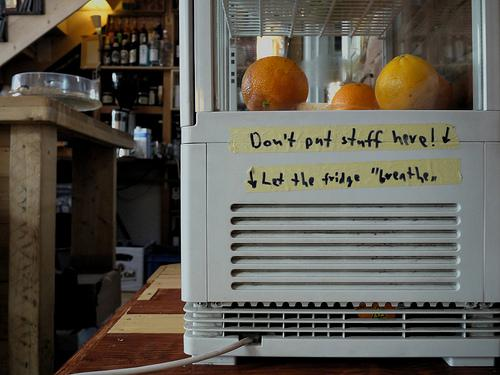Question: what is being stored in the device on the right?
Choices:
A. Meat.
B. Drinks.
C. Wood.
D. Fruit.
Answer with the letter. Answer: D Question: what color ink is the sign written in?
Choices:
A. Green.
B. Black.
C. Blue.
D. Red.
Answer with the letter. Answer: B Question: what color is the table on the left?
Choices:
A. Green.
B. Blue.
C. Red.
D. Brown.
Answer with the letter. Answer: D Question: what does the first sentence on the sign say?
Choices:
A. Don't take stuff here.
B. Don't place stuff here.
C. Don't stop here.
D. Don't put stuff here.
Answer with the letter. Answer: D Question: what does the second sentence on the sign say?
Choices:
A. Let the fridge break.
B. Get the fridge out.
C. Clean the fridge please.
D. Let the fridge breathe.
Answer with the letter. Answer: D Question: why did someone write on the device?
Choices:
A. To leave a message.
B. To greet the person hello.
C. To keep the vent from being blocked.
D. To show off his writing.
Answer with the letter. Answer: C 